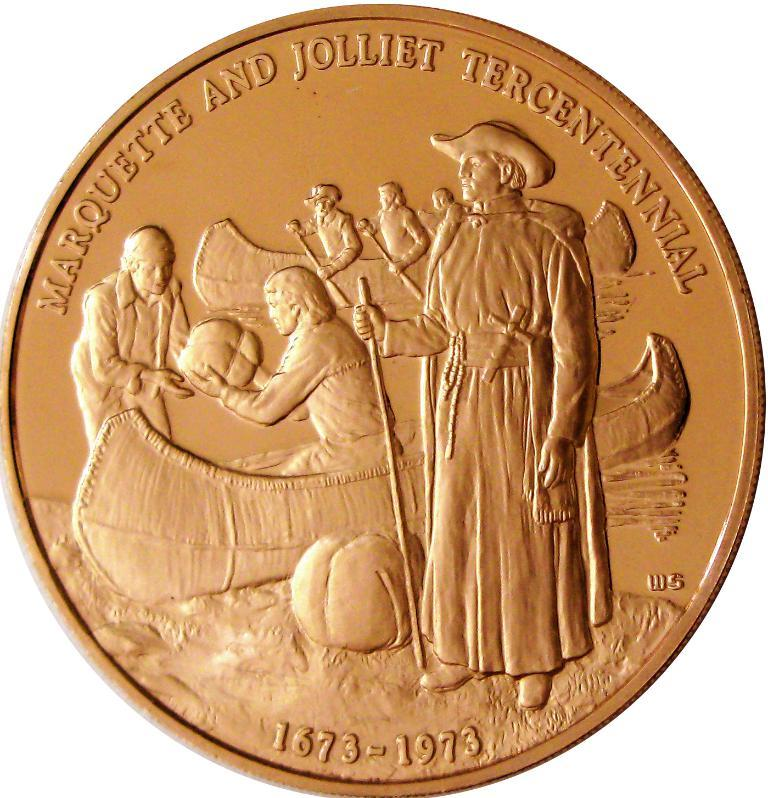<image>
Render a clear and concise summary of the photo. A coin with a boat on the front has the years 1673-1973 written at the bottom. 